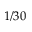Convert formula to latex. <formula><loc_0><loc_0><loc_500><loc_500>1 / 3 0</formula> 